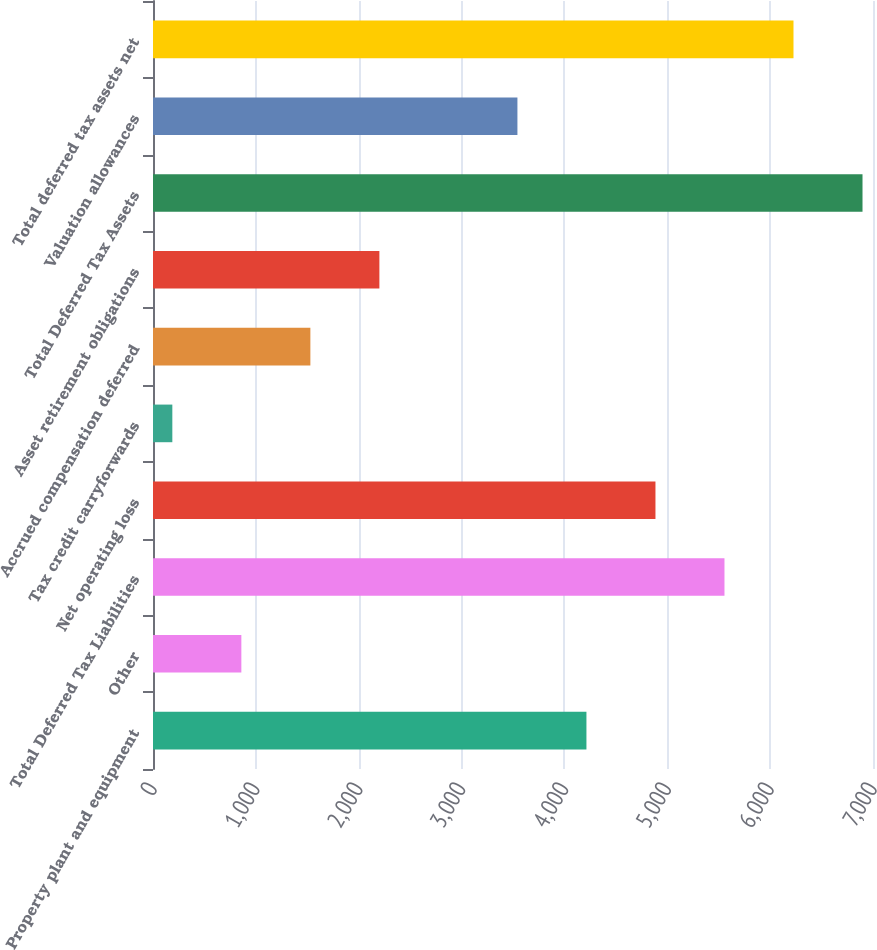Convert chart. <chart><loc_0><loc_0><loc_500><loc_500><bar_chart><fcel>Property plant and equipment<fcel>Other<fcel>Total Deferred Tax Liabilities<fcel>Net operating loss<fcel>Tax credit carryforwards<fcel>Accrued compensation deferred<fcel>Asset retirement obligations<fcel>Total Deferred Tax Assets<fcel>Valuation allowances<fcel>Total deferred tax assets net<nl><fcel>4214<fcel>859<fcel>5556<fcel>4885<fcel>188<fcel>1530<fcel>2201<fcel>6898<fcel>3543<fcel>6227<nl></chart> 